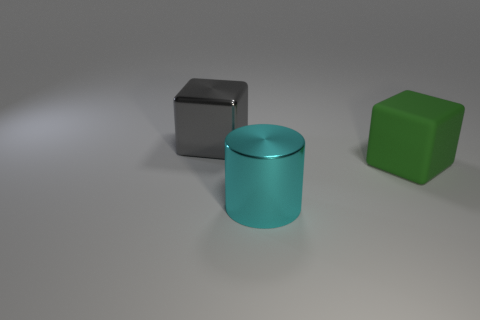What is the material of the large cube to the left of the thing in front of the large cube that is on the right side of the big cyan metallic thing?
Provide a short and direct response. Metal. Are there more large green matte blocks on the left side of the gray thing than gray metallic things in front of the green thing?
Your answer should be compact. No. How many big blue cubes are made of the same material as the cyan object?
Your response must be concise. 0. Does the large shiny thing that is in front of the large rubber object have the same shape as the large object that is behind the rubber block?
Ensure brevity in your answer.  No. The big object in front of the big green rubber block is what color?
Provide a short and direct response. Cyan. Are there any yellow matte things that have the same shape as the large gray thing?
Provide a short and direct response. No. What is the material of the green thing?
Provide a succinct answer. Rubber. There is a object that is on the left side of the matte object and in front of the gray thing; what size is it?
Give a very brief answer. Large. How many green rubber objects are there?
Your response must be concise. 1. Are there fewer green metal blocks than big cyan metallic objects?
Your answer should be compact. Yes. 